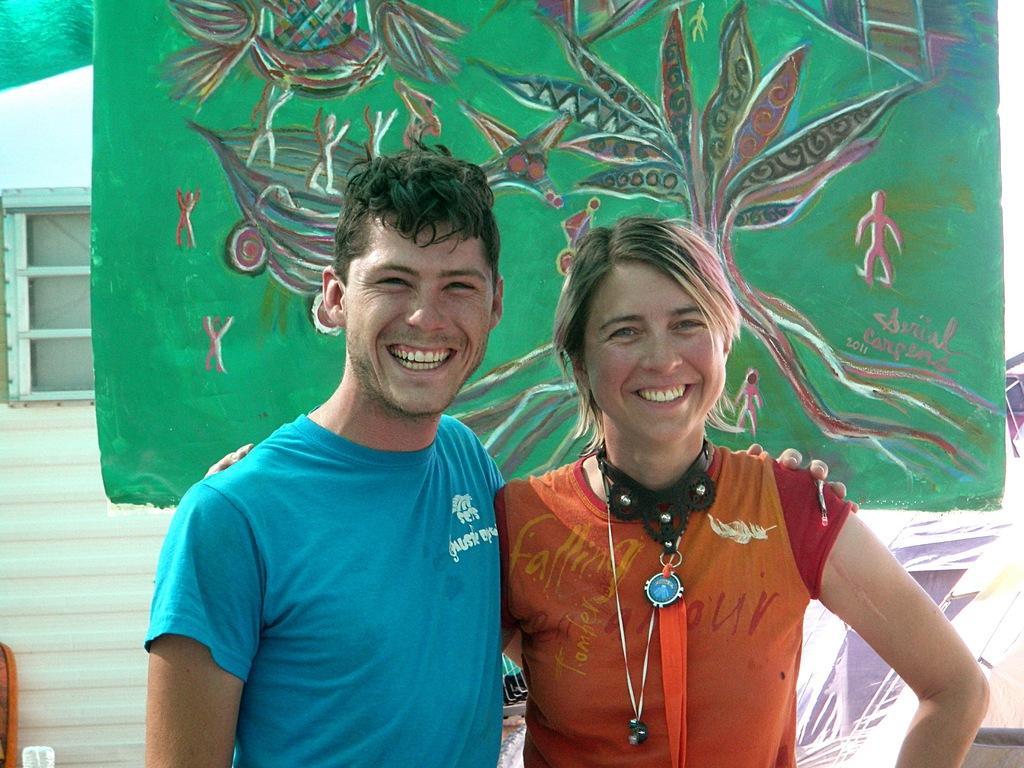How would you summarize this image in a sentence or two? Here a man and a woman wearing t-shirts, smiling and giving pose for the picture. At the back of these people there is a board on which I can see some paintings. In the background there is a wall along with the window. 